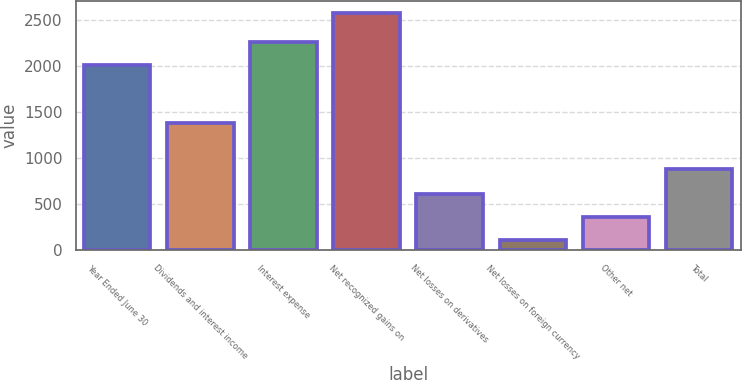Convert chart. <chart><loc_0><loc_0><loc_500><loc_500><bar_chart><fcel>Year Ended June 30<fcel>Dividends and interest income<fcel>Interest expense<fcel>Net recognized gains on<fcel>Net losses on derivatives<fcel>Net losses on foreign currency<fcel>Other net<fcel>Total<nl><fcel>2017<fcel>1387<fcel>2264.2<fcel>2583<fcel>605.4<fcel>111<fcel>358.2<fcel>876<nl></chart> 